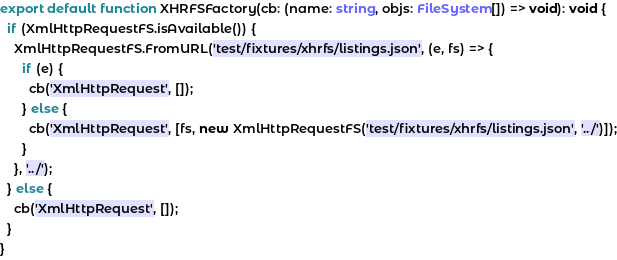Convert code to text. <code><loc_0><loc_0><loc_500><loc_500><_TypeScript_>export default function XHRFSFactory(cb: (name: string, objs: FileSystem[]) => void): void {
  if (XmlHttpRequestFS.isAvailable()) {
    XmlHttpRequestFS.FromURL('test/fixtures/xhrfs/listings.json', (e, fs) => {
      if (e) {
        cb('XmlHttpRequest', []);
      } else {
        cb('XmlHttpRequest', [fs, new XmlHttpRequestFS('test/fixtures/xhrfs/listings.json', '../')]);
      }
    }, '../');
  } else {
    cb('XmlHttpRequest', []);
  }
}
</code> 